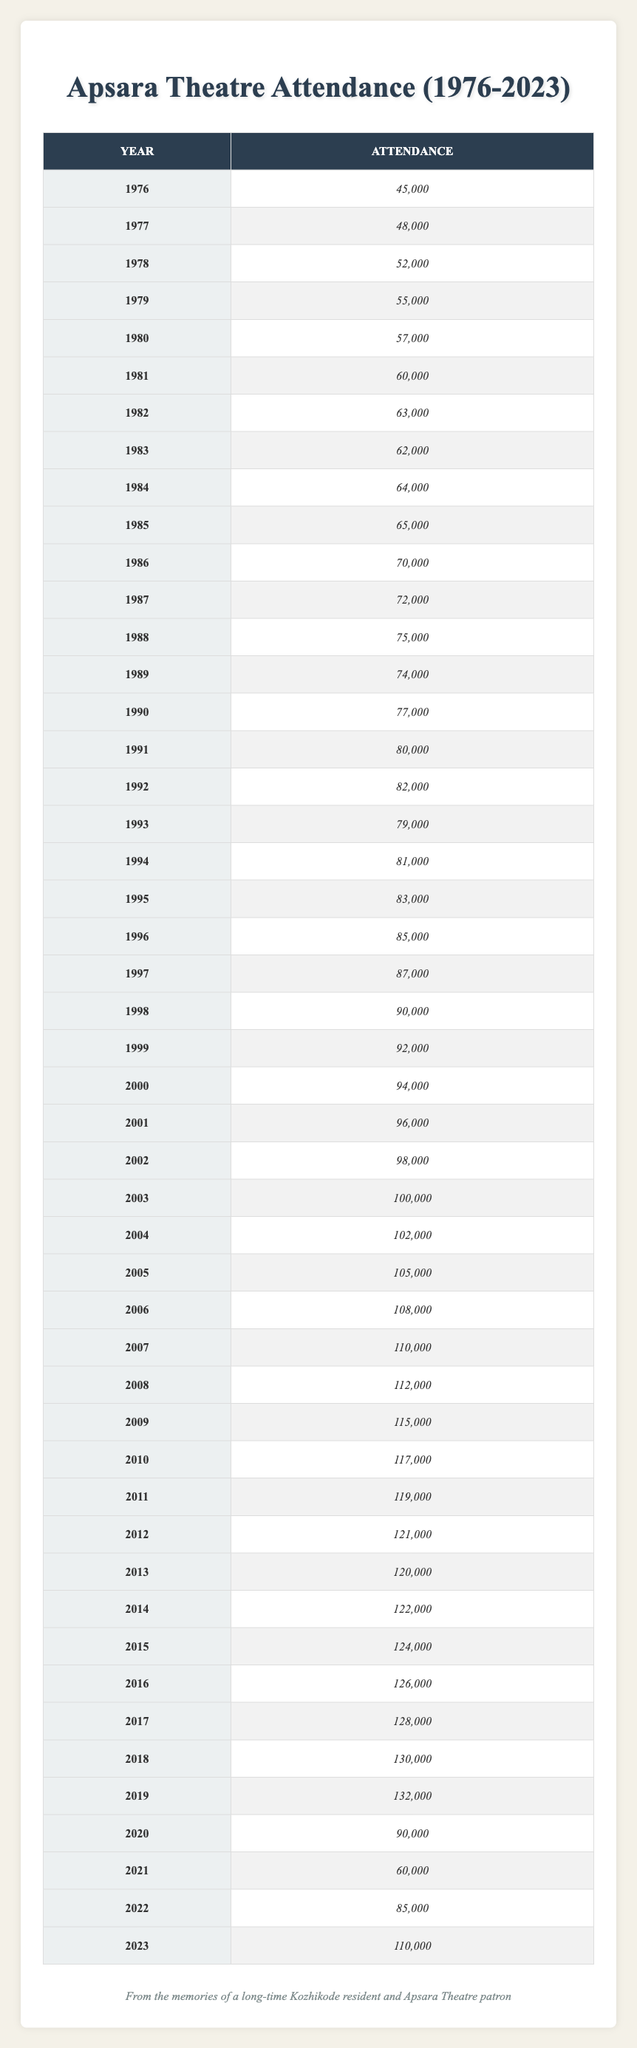What was the attendance at Apsara Theatre in 1985? Looking at the table, I find the row for the year 1985, which lists the attendance as 65,000.
Answer: 65,000 What was the total attendance from 2000 to 2005? I will add the attendance numbers for the years 2000 (94,000), 2001 (96,000), 2002 (98,000), 2003 (100,000), 2004 (102,000), and 2005 (105,000). The total is 94,000 + 96,000 + 98,000 + 100,000 + 102,000 + 105,000 = 595,000.
Answer: 595,000 Did the attendance ever drop below 60,000 during the years recorded? By scanning the table, there are rows with attendance values, and the attendance in 2021 is recorded as 60,000, while there are no years listed with a lower number. Therefore, the statement is false.
Answer: No What year had the highest attendance and how much was it? I need to look through the attendance numbers for each year and identify the maximum value. Upon review, the maximum attendance of 132,000 was in 2019.
Answer: 2019, 132,000 Which year experienced a notable drop in attendance after 2019? Comparing the attendance for 2019 (132,000) and the following years, I see that 2020 had an attendance of 90,000 and then 60,000 in 2021, illustrating a significant decline. This indicates a noticeable drop in attendance for 2020.
Answer: 2020 What is the average attendance from 1990 to 1995? To find the average, I will first add the attendance numbers from these years: 77,000 (1990), 80,000 (1991), 82,000 (1992), 79,000 (1993), 81,000 (1994), and 83,000 (1995). The total is 77,000 + 80,000 + 82,000 + 79,000 + 81,000 + 83,000 = 482,000. Since there are 6 years, I divide 482,000 by 6, giving an average of approximately 80,333.
Answer: 80,333 How many years did attendance exceed 100,000? I will look at the rows for each year, and I find that the years with attendance exceeding 100,000 are from 2003 to 2019, which totals 17 years (2003, 2004, 2005, 2006, 2007, 2008, 2009, 2010, 2011, 2012, 2013, 2014, 2015, 2016, 2017, 2018, and 2019).
Answer: 17 years In which year was the attendance closest to 110,000 without exceeding it? Reviewing the table for attendance numbers, the year 2011 shows an attendance of 119,000 which exceeds 110,000, while the previous year 2010 contains 117,000, and 2023 shows 110,000 as well. The closest without exceeding is 2012 at 121,000. Therefore, focusing on values closest and not exceeding we have 2019 at 132,000 being excluded.
Answer: 2019 at 132,000 